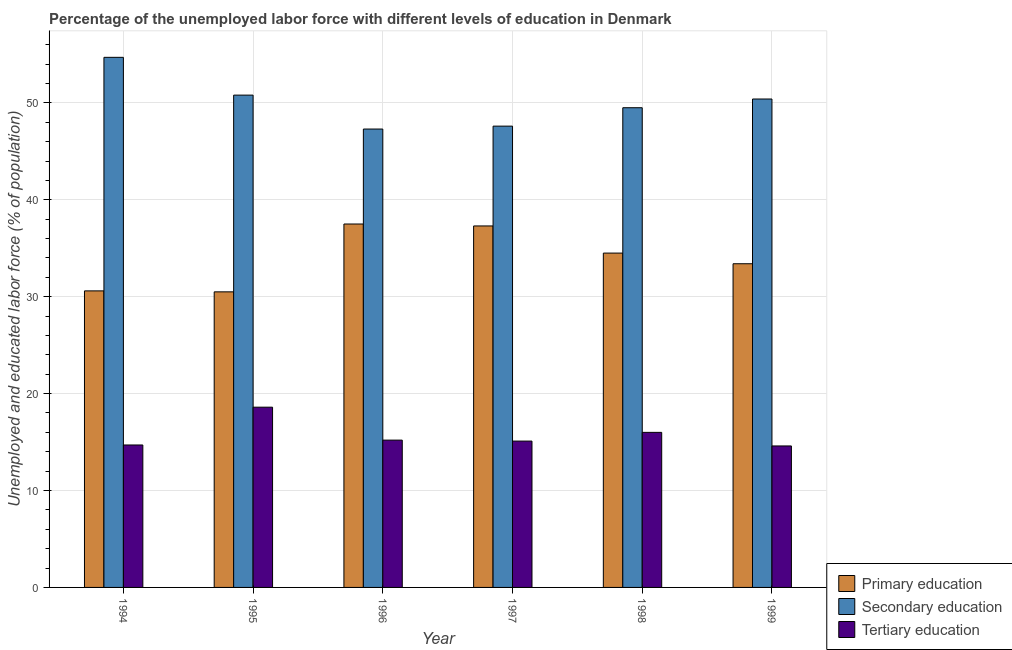Are the number of bars per tick equal to the number of legend labels?
Give a very brief answer. Yes. Are the number of bars on each tick of the X-axis equal?
Provide a succinct answer. Yes. How many bars are there on the 5th tick from the right?
Provide a succinct answer. 3. What is the label of the 4th group of bars from the left?
Keep it short and to the point. 1997. What is the percentage of labor force who received primary education in 1995?
Ensure brevity in your answer.  30.5. Across all years, what is the maximum percentage of labor force who received secondary education?
Give a very brief answer. 54.7. Across all years, what is the minimum percentage of labor force who received primary education?
Keep it short and to the point. 30.5. In which year was the percentage of labor force who received secondary education minimum?
Offer a very short reply. 1996. What is the total percentage of labor force who received primary education in the graph?
Give a very brief answer. 203.8. What is the difference between the percentage of labor force who received secondary education in 1995 and that in 1998?
Keep it short and to the point. 1.3. What is the difference between the percentage of labor force who received secondary education in 1999 and the percentage of labor force who received primary education in 1994?
Provide a short and direct response. -4.3. What is the average percentage of labor force who received secondary education per year?
Your answer should be very brief. 50.05. In the year 1999, what is the difference between the percentage of labor force who received secondary education and percentage of labor force who received primary education?
Offer a very short reply. 0. In how many years, is the percentage of labor force who received secondary education greater than 10 %?
Offer a very short reply. 6. What is the ratio of the percentage of labor force who received secondary education in 1996 to that in 1998?
Offer a terse response. 0.96. Is the difference between the percentage of labor force who received primary education in 1997 and 1999 greater than the difference between the percentage of labor force who received secondary education in 1997 and 1999?
Make the answer very short. No. What is the difference between the highest and the second highest percentage of labor force who received secondary education?
Provide a short and direct response. 3.9. What is the difference between the highest and the lowest percentage of labor force who received secondary education?
Keep it short and to the point. 7.4. In how many years, is the percentage of labor force who received primary education greater than the average percentage of labor force who received primary education taken over all years?
Your response must be concise. 3. What does the 3rd bar from the left in 1999 represents?
Your answer should be compact. Tertiary education. What does the 3rd bar from the right in 1998 represents?
Offer a terse response. Primary education. Is it the case that in every year, the sum of the percentage of labor force who received primary education and percentage of labor force who received secondary education is greater than the percentage of labor force who received tertiary education?
Keep it short and to the point. Yes. How many bars are there?
Offer a very short reply. 18. How many years are there in the graph?
Ensure brevity in your answer.  6. What is the difference between two consecutive major ticks on the Y-axis?
Give a very brief answer. 10. Does the graph contain any zero values?
Make the answer very short. No. Where does the legend appear in the graph?
Make the answer very short. Bottom right. How many legend labels are there?
Your response must be concise. 3. What is the title of the graph?
Give a very brief answer. Percentage of the unemployed labor force with different levels of education in Denmark. What is the label or title of the X-axis?
Offer a very short reply. Year. What is the label or title of the Y-axis?
Give a very brief answer. Unemployed and educated labor force (% of population). What is the Unemployed and educated labor force (% of population) in Primary education in 1994?
Offer a terse response. 30.6. What is the Unemployed and educated labor force (% of population) of Secondary education in 1994?
Your answer should be very brief. 54.7. What is the Unemployed and educated labor force (% of population) of Tertiary education in 1994?
Ensure brevity in your answer.  14.7. What is the Unemployed and educated labor force (% of population) of Primary education in 1995?
Offer a terse response. 30.5. What is the Unemployed and educated labor force (% of population) in Secondary education in 1995?
Ensure brevity in your answer.  50.8. What is the Unemployed and educated labor force (% of population) in Tertiary education in 1995?
Your response must be concise. 18.6. What is the Unemployed and educated labor force (% of population) of Primary education in 1996?
Ensure brevity in your answer.  37.5. What is the Unemployed and educated labor force (% of population) of Secondary education in 1996?
Ensure brevity in your answer.  47.3. What is the Unemployed and educated labor force (% of population) in Tertiary education in 1996?
Your answer should be compact. 15.2. What is the Unemployed and educated labor force (% of population) in Primary education in 1997?
Your response must be concise. 37.3. What is the Unemployed and educated labor force (% of population) in Secondary education in 1997?
Keep it short and to the point. 47.6. What is the Unemployed and educated labor force (% of population) in Tertiary education in 1997?
Your answer should be very brief. 15.1. What is the Unemployed and educated labor force (% of population) in Primary education in 1998?
Provide a short and direct response. 34.5. What is the Unemployed and educated labor force (% of population) in Secondary education in 1998?
Provide a short and direct response. 49.5. What is the Unemployed and educated labor force (% of population) of Primary education in 1999?
Give a very brief answer. 33.4. What is the Unemployed and educated labor force (% of population) of Secondary education in 1999?
Your response must be concise. 50.4. What is the Unemployed and educated labor force (% of population) of Tertiary education in 1999?
Your response must be concise. 14.6. Across all years, what is the maximum Unemployed and educated labor force (% of population) of Primary education?
Your response must be concise. 37.5. Across all years, what is the maximum Unemployed and educated labor force (% of population) of Secondary education?
Your response must be concise. 54.7. Across all years, what is the maximum Unemployed and educated labor force (% of population) of Tertiary education?
Your answer should be very brief. 18.6. Across all years, what is the minimum Unemployed and educated labor force (% of population) of Primary education?
Ensure brevity in your answer.  30.5. Across all years, what is the minimum Unemployed and educated labor force (% of population) in Secondary education?
Your answer should be compact. 47.3. Across all years, what is the minimum Unemployed and educated labor force (% of population) of Tertiary education?
Your answer should be very brief. 14.6. What is the total Unemployed and educated labor force (% of population) in Primary education in the graph?
Provide a short and direct response. 203.8. What is the total Unemployed and educated labor force (% of population) in Secondary education in the graph?
Make the answer very short. 300.3. What is the total Unemployed and educated labor force (% of population) in Tertiary education in the graph?
Provide a succinct answer. 94.2. What is the difference between the Unemployed and educated labor force (% of population) in Tertiary education in 1994 and that in 1995?
Provide a short and direct response. -3.9. What is the difference between the Unemployed and educated labor force (% of population) of Tertiary education in 1994 and that in 1996?
Your answer should be very brief. -0.5. What is the difference between the Unemployed and educated labor force (% of population) of Secondary education in 1994 and that in 1997?
Your answer should be very brief. 7.1. What is the difference between the Unemployed and educated labor force (% of population) in Primary education in 1994 and that in 1998?
Your answer should be compact. -3.9. What is the difference between the Unemployed and educated labor force (% of population) in Secondary education in 1994 and that in 1998?
Offer a terse response. 5.2. What is the difference between the Unemployed and educated labor force (% of population) in Tertiary education in 1994 and that in 1999?
Provide a succinct answer. 0.1. What is the difference between the Unemployed and educated labor force (% of population) of Secondary education in 1995 and that in 1996?
Give a very brief answer. 3.5. What is the difference between the Unemployed and educated labor force (% of population) in Tertiary education in 1995 and that in 1996?
Provide a succinct answer. 3.4. What is the difference between the Unemployed and educated labor force (% of population) of Primary education in 1995 and that in 1997?
Offer a very short reply. -6.8. What is the difference between the Unemployed and educated labor force (% of population) of Tertiary education in 1995 and that in 1997?
Ensure brevity in your answer.  3.5. What is the difference between the Unemployed and educated labor force (% of population) of Primary education in 1995 and that in 1998?
Offer a very short reply. -4. What is the difference between the Unemployed and educated labor force (% of population) of Secondary education in 1995 and that in 1999?
Offer a very short reply. 0.4. What is the difference between the Unemployed and educated labor force (% of population) of Secondary education in 1996 and that in 1997?
Ensure brevity in your answer.  -0.3. What is the difference between the Unemployed and educated labor force (% of population) in Primary education in 1996 and that in 1998?
Your response must be concise. 3. What is the difference between the Unemployed and educated labor force (% of population) in Tertiary education in 1996 and that in 1998?
Your response must be concise. -0.8. What is the difference between the Unemployed and educated labor force (% of population) in Secondary education in 1996 and that in 1999?
Provide a short and direct response. -3.1. What is the difference between the Unemployed and educated labor force (% of population) of Tertiary education in 1996 and that in 1999?
Ensure brevity in your answer.  0.6. What is the difference between the Unemployed and educated labor force (% of population) of Primary education in 1997 and that in 1998?
Keep it short and to the point. 2.8. What is the difference between the Unemployed and educated labor force (% of population) of Secondary education in 1997 and that in 1998?
Your answer should be very brief. -1.9. What is the difference between the Unemployed and educated labor force (% of population) in Tertiary education in 1997 and that in 1998?
Make the answer very short. -0.9. What is the difference between the Unemployed and educated labor force (% of population) of Primary education in 1998 and that in 1999?
Your answer should be compact. 1.1. What is the difference between the Unemployed and educated labor force (% of population) in Secondary education in 1998 and that in 1999?
Ensure brevity in your answer.  -0.9. What is the difference between the Unemployed and educated labor force (% of population) of Tertiary education in 1998 and that in 1999?
Provide a succinct answer. 1.4. What is the difference between the Unemployed and educated labor force (% of population) in Primary education in 1994 and the Unemployed and educated labor force (% of population) in Secondary education in 1995?
Your answer should be compact. -20.2. What is the difference between the Unemployed and educated labor force (% of population) of Secondary education in 1994 and the Unemployed and educated labor force (% of population) of Tertiary education in 1995?
Your answer should be compact. 36.1. What is the difference between the Unemployed and educated labor force (% of population) of Primary education in 1994 and the Unemployed and educated labor force (% of population) of Secondary education in 1996?
Your answer should be very brief. -16.7. What is the difference between the Unemployed and educated labor force (% of population) of Primary education in 1994 and the Unemployed and educated labor force (% of population) of Tertiary education in 1996?
Make the answer very short. 15.4. What is the difference between the Unemployed and educated labor force (% of population) of Secondary education in 1994 and the Unemployed and educated labor force (% of population) of Tertiary education in 1996?
Your answer should be compact. 39.5. What is the difference between the Unemployed and educated labor force (% of population) of Primary education in 1994 and the Unemployed and educated labor force (% of population) of Secondary education in 1997?
Offer a very short reply. -17. What is the difference between the Unemployed and educated labor force (% of population) in Secondary education in 1994 and the Unemployed and educated labor force (% of population) in Tertiary education in 1997?
Make the answer very short. 39.6. What is the difference between the Unemployed and educated labor force (% of population) of Primary education in 1994 and the Unemployed and educated labor force (% of population) of Secondary education in 1998?
Offer a very short reply. -18.9. What is the difference between the Unemployed and educated labor force (% of population) in Primary education in 1994 and the Unemployed and educated labor force (% of population) in Tertiary education in 1998?
Ensure brevity in your answer.  14.6. What is the difference between the Unemployed and educated labor force (% of population) in Secondary education in 1994 and the Unemployed and educated labor force (% of population) in Tertiary education in 1998?
Keep it short and to the point. 38.7. What is the difference between the Unemployed and educated labor force (% of population) of Primary education in 1994 and the Unemployed and educated labor force (% of population) of Secondary education in 1999?
Offer a very short reply. -19.8. What is the difference between the Unemployed and educated labor force (% of population) of Secondary education in 1994 and the Unemployed and educated labor force (% of population) of Tertiary education in 1999?
Your answer should be compact. 40.1. What is the difference between the Unemployed and educated labor force (% of population) of Primary education in 1995 and the Unemployed and educated labor force (% of population) of Secondary education in 1996?
Offer a terse response. -16.8. What is the difference between the Unemployed and educated labor force (% of population) of Primary education in 1995 and the Unemployed and educated labor force (% of population) of Tertiary education in 1996?
Keep it short and to the point. 15.3. What is the difference between the Unemployed and educated labor force (% of population) of Secondary education in 1995 and the Unemployed and educated labor force (% of population) of Tertiary education in 1996?
Offer a terse response. 35.6. What is the difference between the Unemployed and educated labor force (% of population) in Primary education in 1995 and the Unemployed and educated labor force (% of population) in Secondary education in 1997?
Ensure brevity in your answer.  -17.1. What is the difference between the Unemployed and educated labor force (% of population) of Primary education in 1995 and the Unemployed and educated labor force (% of population) of Tertiary education in 1997?
Provide a short and direct response. 15.4. What is the difference between the Unemployed and educated labor force (% of population) of Secondary education in 1995 and the Unemployed and educated labor force (% of population) of Tertiary education in 1997?
Provide a short and direct response. 35.7. What is the difference between the Unemployed and educated labor force (% of population) of Primary education in 1995 and the Unemployed and educated labor force (% of population) of Tertiary education in 1998?
Your answer should be very brief. 14.5. What is the difference between the Unemployed and educated labor force (% of population) of Secondary education in 1995 and the Unemployed and educated labor force (% of population) of Tertiary education in 1998?
Ensure brevity in your answer.  34.8. What is the difference between the Unemployed and educated labor force (% of population) of Primary education in 1995 and the Unemployed and educated labor force (% of population) of Secondary education in 1999?
Ensure brevity in your answer.  -19.9. What is the difference between the Unemployed and educated labor force (% of population) in Primary education in 1995 and the Unemployed and educated labor force (% of population) in Tertiary education in 1999?
Provide a short and direct response. 15.9. What is the difference between the Unemployed and educated labor force (% of population) in Secondary education in 1995 and the Unemployed and educated labor force (% of population) in Tertiary education in 1999?
Ensure brevity in your answer.  36.2. What is the difference between the Unemployed and educated labor force (% of population) in Primary education in 1996 and the Unemployed and educated labor force (% of population) in Tertiary education in 1997?
Provide a succinct answer. 22.4. What is the difference between the Unemployed and educated labor force (% of population) in Secondary education in 1996 and the Unemployed and educated labor force (% of population) in Tertiary education in 1997?
Offer a terse response. 32.2. What is the difference between the Unemployed and educated labor force (% of population) in Secondary education in 1996 and the Unemployed and educated labor force (% of population) in Tertiary education in 1998?
Offer a terse response. 31.3. What is the difference between the Unemployed and educated labor force (% of population) of Primary education in 1996 and the Unemployed and educated labor force (% of population) of Tertiary education in 1999?
Make the answer very short. 22.9. What is the difference between the Unemployed and educated labor force (% of population) of Secondary education in 1996 and the Unemployed and educated labor force (% of population) of Tertiary education in 1999?
Ensure brevity in your answer.  32.7. What is the difference between the Unemployed and educated labor force (% of population) of Primary education in 1997 and the Unemployed and educated labor force (% of population) of Tertiary education in 1998?
Offer a terse response. 21.3. What is the difference between the Unemployed and educated labor force (% of population) in Secondary education in 1997 and the Unemployed and educated labor force (% of population) in Tertiary education in 1998?
Your answer should be compact. 31.6. What is the difference between the Unemployed and educated labor force (% of population) of Primary education in 1997 and the Unemployed and educated labor force (% of population) of Tertiary education in 1999?
Offer a terse response. 22.7. What is the difference between the Unemployed and educated labor force (% of population) of Secondary education in 1997 and the Unemployed and educated labor force (% of population) of Tertiary education in 1999?
Ensure brevity in your answer.  33. What is the difference between the Unemployed and educated labor force (% of population) of Primary education in 1998 and the Unemployed and educated labor force (% of population) of Secondary education in 1999?
Offer a very short reply. -15.9. What is the difference between the Unemployed and educated labor force (% of population) in Secondary education in 1998 and the Unemployed and educated labor force (% of population) in Tertiary education in 1999?
Give a very brief answer. 34.9. What is the average Unemployed and educated labor force (% of population) in Primary education per year?
Keep it short and to the point. 33.97. What is the average Unemployed and educated labor force (% of population) of Secondary education per year?
Offer a terse response. 50.05. What is the average Unemployed and educated labor force (% of population) in Tertiary education per year?
Keep it short and to the point. 15.7. In the year 1994, what is the difference between the Unemployed and educated labor force (% of population) of Primary education and Unemployed and educated labor force (% of population) of Secondary education?
Keep it short and to the point. -24.1. In the year 1994, what is the difference between the Unemployed and educated labor force (% of population) of Primary education and Unemployed and educated labor force (% of population) of Tertiary education?
Keep it short and to the point. 15.9. In the year 1994, what is the difference between the Unemployed and educated labor force (% of population) in Secondary education and Unemployed and educated labor force (% of population) in Tertiary education?
Ensure brevity in your answer.  40. In the year 1995, what is the difference between the Unemployed and educated labor force (% of population) of Primary education and Unemployed and educated labor force (% of population) of Secondary education?
Your answer should be very brief. -20.3. In the year 1995, what is the difference between the Unemployed and educated labor force (% of population) in Primary education and Unemployed and educated labor force (% of population) in Tertiary education?
Offer a very short reply. 11.9. In the year 1995, what is the difference between the Unemployed and educated labor force (% of population) of Secondary education and Unemployed and educated labor force (% of population) of Tertiary education?
Offer a very short reply. 32.2. In the year 1996, what is the difference between the Unemployed and educated labor force (% of population) of Primary education and Unemployed and educated labor force (% of population) of Secondary education?
Keep it short and to the point. -9.8. In the year 1996, what is the difference between the Unemployed and educated labor force (% of population) in Primary education and Unemployed and educated labor force (% of population) in Tertiary education?
Provide a succinct answer. 22.3. In the year 1996, what is the difference between the Unemployed and educated labor force (% of population) in Secondary education and Unemployed and educated labor force (% of population) in Tertiary education?
Give a very brief answer. 32.1. In the year 1997, what is the difference between the Unemployed and educated labor force (% of population) in Primary education and Unemployed and educated labor force (% of population) in Tertiary education?
Offer a terse response. 22.2. In the year 1997, what is the difference between the Unemployed and educated labor force (% of population) of Secondary education and Unemployed and educated labor force (% of population) of Tertiary education?
Provide a short and direct response. 32.5. In the year 1998, what is the difference between the Unemployed and educated labor force (% of population) of Primary education and Unemployed and educated labor force (% of population) of Secondary education?
Keep it short and to the point. -15. In the year 1998, what is the difference between the Unemployed and educated labor force (% of population) in Secondary education and Unemployed and educated labor force (% of population) in Tertiary education?
Offer a very short reply. 33.5. In the year 1999, what is the difference between the Unemployed and educated labor force (% of population) in Secondary education and Unemployed and educated labor force (% of population) in Tertiary education?
Your response must be concise. 35.8. What is the ratio of the Unemployed and educated labor force (% of population) in Primary education in 1994 to that in 1995?
Give a very brief answer. 1. What is the ratio of the Unemployed and educated labor force (% of population) of Secondary education in 1994 to that in 1995?
Your answer should be very brief. 1.08. What is the ratio of the Unemployed and educated labor force (% of population) of Tertiary education in 1994 to that in 1995?
Provide a short and direct response. 0.79. What is the ratio of the Unemployed and educated labor force (% of population) of Primary education in 1994 to that in 1996?
Provide a short and direct response. 0.82. What is the ratio of the Unemployed and educated labor force (% of population) of Secondary education in 1994 to that in 1996?
Make the answer very short. 1.16. What is the ratio of the Unemployed and educated labor force (% of population) in Tertiary education in 1994 to that in 1996?
Ensure brevity in your answer.  0.97. What is the ratio of the Unemployed and educated labor force (% of population) of Primary education in 1994 to that in 1997?
Your answer should be very brief. 0.82. What is the ratio of the Unemployed and educated labor force (% of population) in Secondary education in 1994 to that in 1997?
Make the answer very short. 1.15. What is the ratio of the Unemployed and educated labor force (% of population) in Tertiary education in 1994 to that in 1997?
Provide a succinct answer. 0.97. What is the ratio of the Unemployed and educated labor force (% of population) in Primary education in 1994 to that in 1998?
Make the answer very short. 0.89. What is the ratio of the Unemployed and educated labor force (% of population) in Secondary education in 1994 to that in 1998?
Your answer should be compact. 1.11. What is the ratio of the Unemployed and educated labor force (% of population) of Tertiary education in 1994 to that in 1998?
Provide a short and direct response. 0.92. What is the ratio of the Unemployed and educated labor force (% of population) of Primary education in 1994 to that in 1999?
Make the answer very short. 0.92. What is the ratio of the Unemployed and educated labor force (% of population) of Secondary education in 1994 to that in 1999?
Offer a terse response. 1.09. What is the ratio of the Unemployed and educated labor force (% of population) in Tertiary education in 1994 to that in 1999?
Offer a terse response. 1.01. What is the ratio of the Unemployed and educated labor force (% of population) in Primary education in 1995 to that in 1996?
Make the answer very short. 0.81. What is the ratio of the Unemployed and educated labor force (% of population) of Secondary education in 1995 to that in 1996?
Provide a short and direct response. 1.07. What is the ratio of the Unemployed and educated labor force (% of population) of Tertiary education in 1995 to that in 1996?
Your response must be concise. 1.22. What is the ratio of the Unemployed and educated labor force (% of population) in Primary education in 1995 to that in 1997?
Offer a very short reply. 0.82. What is the ratio of the Unemployed and educated labor force (% of population) in Secondary education in 1995 to that in 1997?
Ensure brevity in your answer.  1.07. What is the ratio of the Unemployed and educated labor force (% of population) in Tertiary education in 1995 to that in 1997?
Provide a succinct answer. 1.23. What is the ratio of the Unemployed and educated labor force (% of population) of Primary education in 1995 to that in 1998?
Your answer should be very brief. 0.88. What is the ratio of the Unemployed and educated labor force (% of population) of Secondary education in 1995 to that in 1998?
Make the answer very short. 1.03. What is the ratio of the Unemployed and educated labor force (% of population) of Tertiary education in 1995 to that in 1998?
Your answer should be compact. 1.16. What is the ratio of the Unemployed and educated labor force (% of population) of Primary education in 1995 to that in 1999?
Ensure brevity in your answer.  0.91. What is the ratio of the Unemployed and educated labor force (% of population) of Secondary education in 1995 to that in 1999?
Your answer should be compact. 1.01. What is the ratio of the Unemployed and educated labor force (% of population) of Tertiary education in 1995 to that in 1999?
Give a very brief answer. 1.27. What is the ratio of the Unemployed and educated labor force (% of population) in Primary education in 1996 to that in 1997?
Your answer should be compact. 1.01. What is the ratio of the Unemployed and educated labor force (% of population) in Tertiary education in 1996 to that in 1997?
Provide a short and direct response. 1.01. What is the ratio of the Unemployed and educated labor force (% of population) of Primary education in 1996 to that in 1998?
Offer a terse response. 1.09. What is the ratio of the Unemployed and educated labor force (% of population) of Secondary education in 1996 to that in 1998?
Provide a short and direct response. 0.96. What is the ratio of the Unemployed and educated labor force (% of population) of Primary education in 1996 to that in 1999?
Give a very brief answer. 1.12. What is the ratio of the Unemployed and educated labor force (% of population) in Secondary education in 1996 to that in 1999?
Provide a short and direct response. 0.94. What is the ratio of the Unemployed and educated labor force (% of population) in Tertiary education in 1996 to that in 1999?
Provide a succinct answer. 1.04. What is the ratio of the Unemployed and educated labor force (% of population) of Primary education in 1997 to that in 1998?
Your answer should be very brief. 1.08. What is the ratio of the Unemployed and educated labor force (% of population) in Secondary education in 1997 to that in 1998?
Provide a succinct answer. 0.96. What is the ratio of the Unemployed and educated labor force (% of population) in Tertiary education in 1997 to that in 1998?
Provide a short and direct response. 0.94. What is the ratio of the Unemployed and educated labor force (% of population) in Primary education in 1997 to that in 1999?
Give a very brief answer. 1.12. What is the ratio of the Unemployed and educated labor force (% of population) in Tertiary education in 1997 to that in 1999?
Provide a short and direct response. 1.03. What is the ratio of the Unemployed and educated labor force (% of population) of Primary education in 1998 to that in 1999?
Ensure brevity in your answer.  1.03. What is the ratio of the Unemployed and educated labor force (% of population) of Secondary education in 1998 to that in 1999?
Keep it short and to the point. 0.98. What is the ratio of the Unemployed and educated labor force (% of population) of Tertiary education in 1998 to that in 1999?
Provide a short and direct response. 1.1. What is the difference between the highest and the second highest Unemployed and educated labor force (% of population) of Secondary education?
Provide a succinct answer. 3.9. What is the difference between the highest and the lowest Unemployed and educated labor force (% of population) of Primary education?
Keep it short and to the point. 7. What is the difference between the highest and the lowest Unemployed and educated labor force (% of population) in Secondary education?
Your response must be concise. 7.4. What is the difference between the highest and the lowest Unemployed and educated labor force (% of population) of Tertiary education?
Give a very brief answer. 4. 